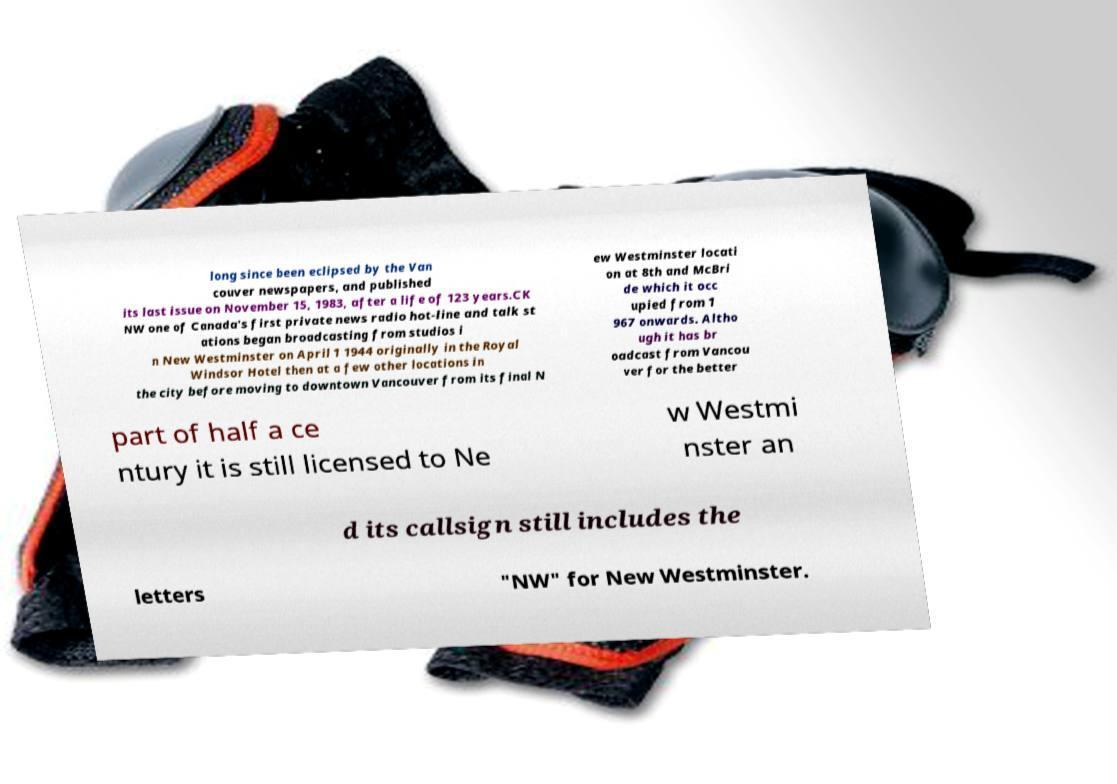Please read and relay the text visible in this image. What does it say? long since been eclipsed by the Van couver newspapers, and published its last issue on November 15, 1983, after a life of 123 years.CK NW one of Canada's first private news radio hot-line and talk st ations began broadcasting from studios i n New Westminster on April 1 1944 originally in the Royal Windsor Hotel then at a few other locations in the city before moving to downtown Vancouver from its final N ew Westminster locati on at 8th and McBri de which it occ upied from 1 967 onwards. Altho ugh it has br oadcast from Vancou ver for the better part of half a ce ntury it is still licensed to Ne w Westmi nster an d its callsign still includes the letters "NW" for New Westminster. 